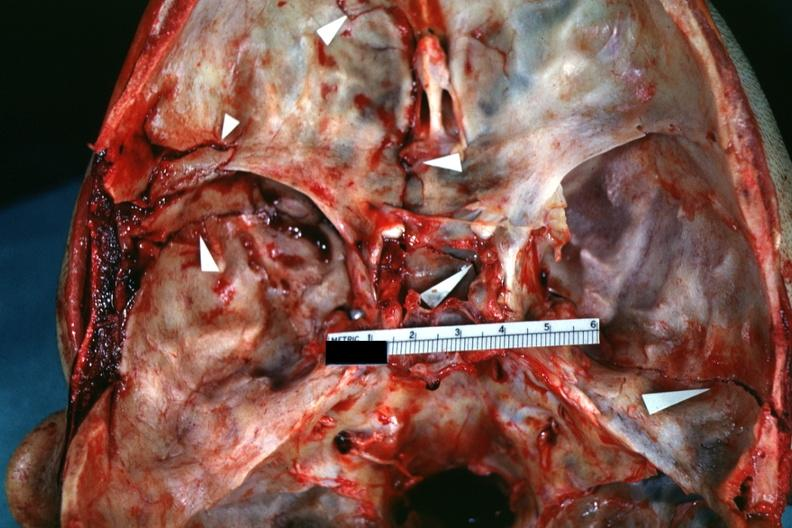does this image show close-up view of lesions slide which is brain from this case?
Answer the question using a single word or phrase. Yes 